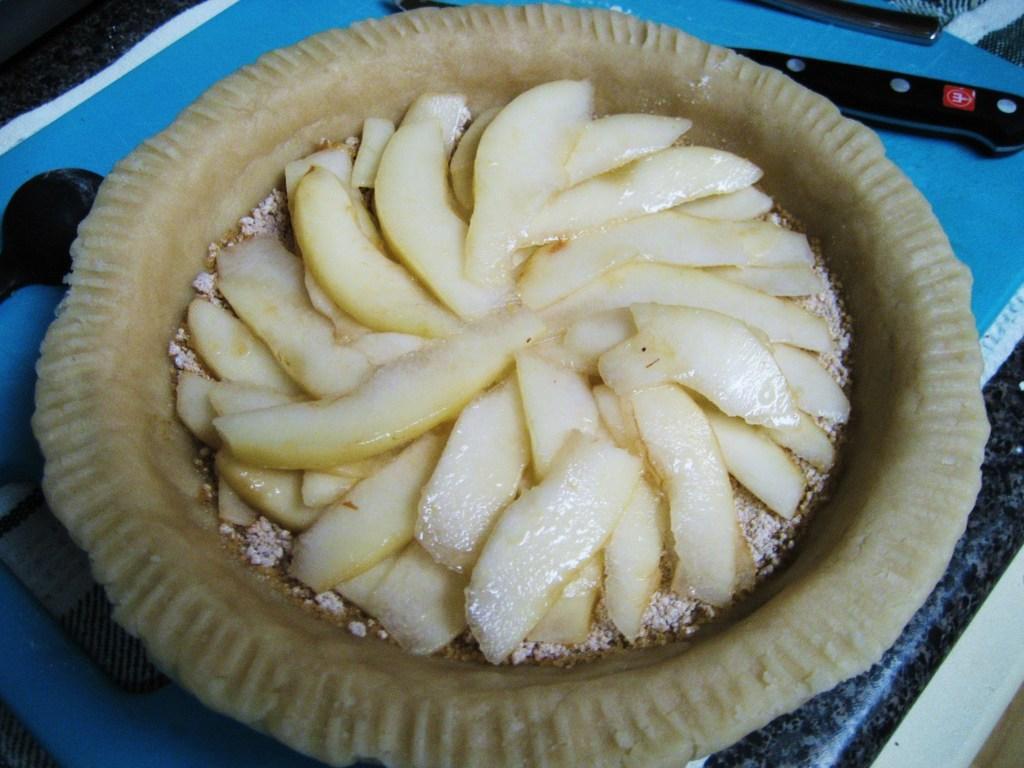Please provide a concise description of this image. In this image, we can see a table, on the table, we can see a bowl with some food. On the right side of the table, we can see a knife and a spoon. In the background, we can see blue color. 